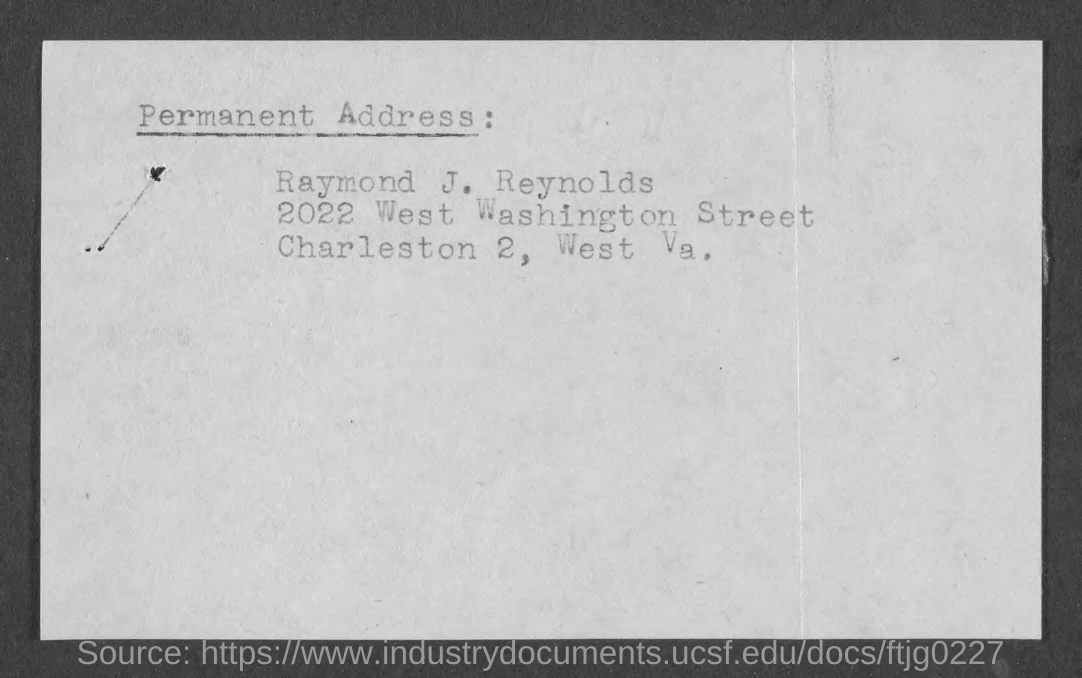Mention a couple of crucial points in this snapshot. The permanent address contains the name of Raymond J. Reynolds. 